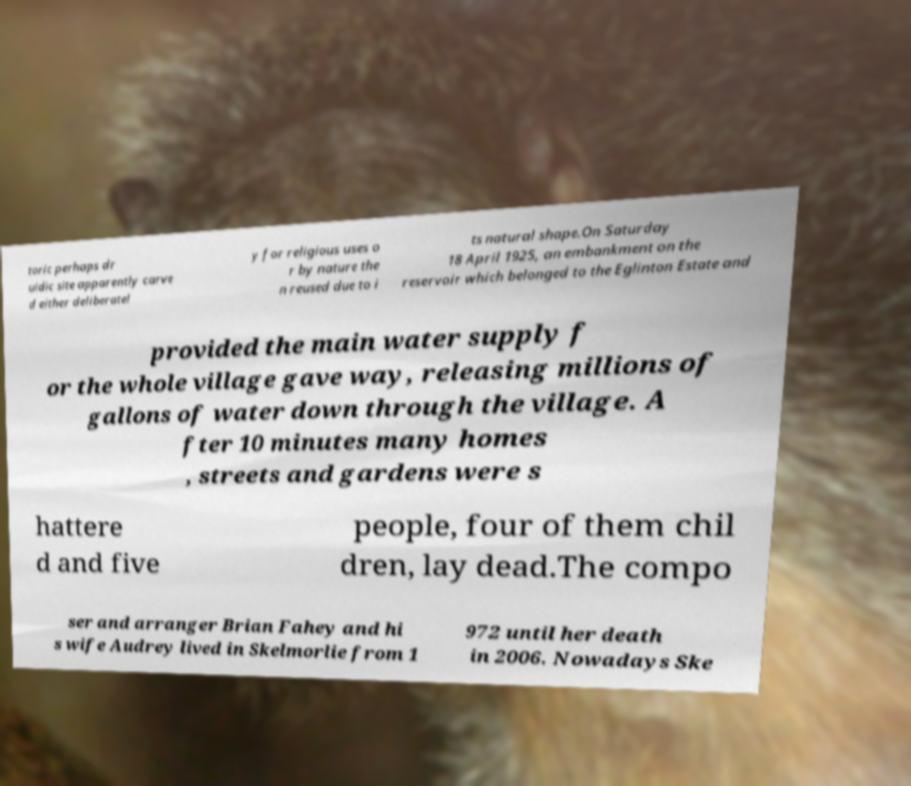Could you assist in decoding the text presented in this image and type it out clearly? toric perhaps dr uidic site apparently carve d either deliberatel y for religious uses o r by nature the n reused due to i ts natural shape.On Saturday 18 April 1925, an embankment on the reservoir which belonged to the Eglinton Estate and provided the main water supply f or the whole village gave way, releasing millions of gallons of water down through the village. A fter 10 minutes many homes , streets and gardens were s hattere d and five people, four of them chil dren, lay dead.The compo ser and arranger Brian Fahey and hi s wife Audrey lived in Skelmorlie from 1 972 until her death in 2006. Nowadays Ske 